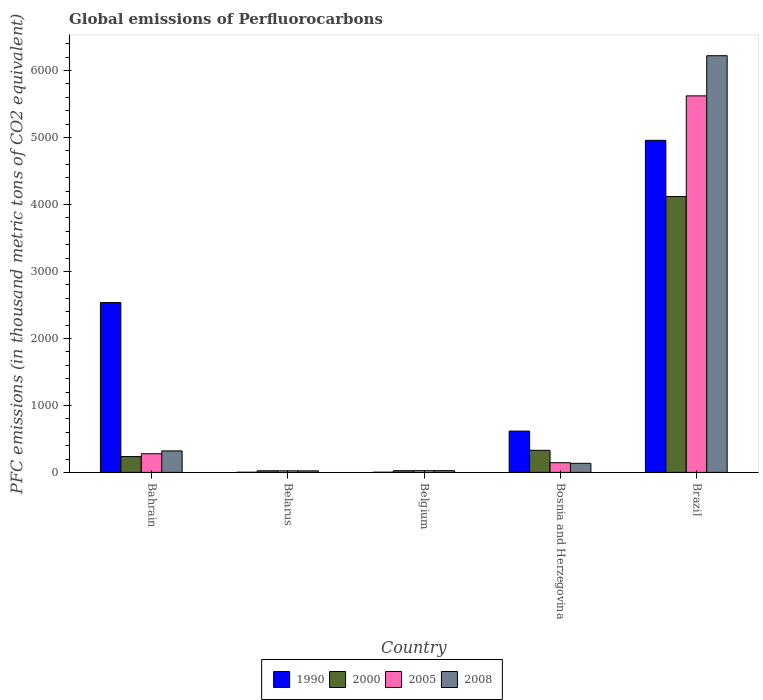How many groups of bars are there?
Give a very brief answer. 5. Are the number of bars per tick equal to the number of legend labels?
Offer a very short reply. Yes. What is the label of the 4th group of bars from the left?
Offer a terse response. Bosnia and Herzegovina. In how many cases, is the number of bars for a given country not equal to the number of legend labels?
Provide a short and direct response. 0. What is the global emissions of Perfluorocarbons in 2008 in Bahrain?
Keep it short and to the point. 320.9. Across all countries, what is the maximum global emissions of Perfluorocarbons in 2000?
Ensure brevity in your answer.  4119.1. In which country was the global emissions of Perfluorocarbons in 2008 maximum?
Provide a short and direct response. Brazil. In which country was the global emissions of Perfluorocarbons in 2008 minimum?
Make the answer very short. Belarus. What is the total global emissions of Perfluorocarbons in 2000 in the graph?
Your answer should be very brief. 4734.2. What is the difference between the global emissions of Perfluorocarbons in 2005 in Belarus and that in Belgium?
Ensure brevity in your answer.  -2.3. What is the difference between the global emissions of Perfluorocarbons in 1990 in Bahrain and the global emissions of Perfluorocarbons in 2005 in Belgium?
Give a very brief answer. 2510. What is the average global emissions of Perfluorocarbons in 2005 per country?
Provide a succinct answer. 1218.84. What is the difference between the global emissions of Perfluorocarbons of/in 1990 and global emissions of Perfluorocarbons of/in 2005 in Bosnia and Herzegovina?
Ensure brevity in your answer.  472.3. What is the ratio of the global emissions of Perfluorocarbons in 2005 in Bahrain to that in Belarus?
Offer a very short reply. 11.91. What is the difference between the highest and the second highest global emissions of Perfluorocarbons in 2008?
Provide a succinct answer. -5900.9. What is the difference between the highest and the lowest global emissions of Perfluorocarbons in 2008?
Give a very brief answer. 6198.7. Is it the case that in every country, the sum of the global emissions of Perfluorocarbons in 2000 and global emissions of Perfluorocarbons in 2008 is greater than the sum of global emissions of Perfluorocarbons in 1990 and global emissions of Perfluorocarbons in 2005?
Offer a very short reply. No. What does the 4th bar from the right in Bosnia and Herzegovina represents?
Your answer should be compact. 1990. How many bars are there?
Provide a succinct answer. 20. Are all the bars in the graph horizontal?
Provide a short and direct response. No. What is the difference between two consecutive major ticks on the Y-axis?
Give a very brief answer. 1000. Does the graph contain any zero values?
Your answer should be compact. No. Does the graph contain grids?
Offer a very short reply. No. Where does the legend appear in the graph?
Give a very brief answer. Bottom center. How many legend labels are there?
Offer a terse response. 4. How are the legend labels stacked?
Offer a terse response. Horizontal. What is the title of the graph?
Give a very brief answer. Global emissions of Perfluorocarbons. Does "1981" appear as one of the legend labels in the graph?
Offer a terse response. No. What is the label or title of the X-axis?
Give a very brief answer. Country. What is the label or title of the Y-axis?
Your answer should be very brief. PFC emissions (in thousand metric tons of CO2 equivalent). What is the PFC emissions (in thousand metric tons of CO2 equivalent) in 1990 in Bahrain?
Make the answer very short. 2535.7. What is the PFC emissions (in thousand metric tons of CO2 equivalent) of 2000 in Bahrain?
Ensure brevity in your answer.  236.1. What is the PFC emissions (in thousand metric tons of CO2 equivalent) in 2005 in Bahrain?
Give a very brief answer. 278.6. What is the PFC emissions (in thousand metric tons of CO2 equivalent) of 2008 in Bahrain?
Provide a succinct answer. 320.9. What is the PFC emissions (in thousand metric tons of CO2 equivalent) in 1990 in Belarus?
Your answer should be compact. 2.6. What is the PFC emissions (in thousand metric tons of CO2 equivalent) in 2000 in Belarus?
Keep it short and to the point. 23.9. What is the PFC emissions (in thousand metric tons of CO2 equivalent) of 2005 in Belarus?
Your answer should be compact. 23.4. What is the PFC emissions (in thousand metric tons of CO2 equivalent) of 2008 in Belarus?
Your answer should be very brief. 23.1. What is the PFC emissions (in thousand metric tons of CO2 equivalent) of 2000 in Belgium?
Your response must be concise. 25.2. What is the PFC emissions (in thousand metric tons of CO2 equivalent) of 2005 in Belgium?
Ensure brevity in your answer.  25.7. What is the PFC emissions (in thousand metric tons of CO2 equivalent) in 1990 in Bosnia and Herzegovina?
Keep it short and to the point. 616.7. What is the PFC emissions (in thousand metric tons of CO2 equivalent) in 2000 in Bosnia and Herzegovina?
Offer a terse response. 329.9. What is the PFC emissions (in thousand metric tons of CO2 equivalent) in 2005 in Bosnia and Herzegovina?
Ensure brevity in your answer.  144.4. What is the PFC emissions (in thousand metric tons of CO2 equivalent) in 2008 in Bosnia and Herzegovina?
Your answer should be compact. 135.6. What is the PFC emissions (in thousand metric tons of CO2 equivalent) of 1990 in Brazil?
Offer a terse response. 4958.1. What is the PFC emissions (in thousand metric tons of CO2 equivalent) in 2000 in Brazil?
Make the answer very short. 4119.1. What is the PFC emissions (in thousand metric tons of CO2 equivalent) of 2005 in Brazil?
Your answer should be very brief. 5622.1. What is the PFC emissions (in thousand metric tons of CO2 equivalent) in 2008 in Brazil?
Your answer should be compact. 6221.8. Across all countries, what is the maximum PFC emissions (in thousand metric tons of CO2 equivalent) of 1990?
Give a very brief answer. 4958.1. Across all countries, what is the maximum PFC emissions (in thousand metric tons of CO2 equivalent) of 2000?
Offer a terse response. 4119.1. Across all countries, what is the maximum PFC emissions (in thousand metric tons of CO2 equivalent) in 2005?
Ensure brevity in your answer.  5622.1. Across all countries, what is the maximum PFC emissions (in thousand metric tons of CO2 equivalent) in 2008?
Offer a terse response. 6221.8. Across all countries, what is the minimum PFC emissions (in thousand metric tons of CO2 equivalent) in 2000?
Provide a succinct answer. 23.9. Across all countries, what is the minimum PFC emissions (in thousand metric tons of CO2 equivalent) of 2005?
Keep it short and to the point. 23.4. Across all countries, what is the minimum PFC emissions (in thousand metric tons of CO2 equivalent) in 2008?
Your answer should be very brief. 23.1. What is the total PFC emissions (in thousand metric tons of CO2 equivalent) of 1990 in the graph?
Provide a succinct answer. 8116. What is the total PFC emissions (in thousand metric tons of CO2 equivalent) of 2000 in the graph?
Offer a terse response. 4734.2. What is the total PFC emissions (in thousand metric tons of CO2 equivalent) of 2005 in the graph?
Make the answer very short. 6094.2. What is the total PFC emissions (in thousand metric tons of CO2 equivalent) of 2008 in the graph?
Ensure brevity in your answer.  6727.4. What is the difference between the PFC emissions (in thousand metric tons of CO2 equivalent) of 1990 in Bahrain and that in Belarus?
Give a very brief answer. 2533.1. What is the difference between the PFC emissions (in thousand metric tons of CO2 equivalent) in 2000 in Bahrain and that in Belarus?
Keep it short and to the point. 212.2. What is the difference between the PFC emissions (in thousand metric tons of CO2 equivalent) in 2005 in Bahrain and that in Belarus?
Make the answer very short. 255.2. What is the difference between the PFC emissions (in thousand metric tons of CO2 equivalent) in 2008 in Bahrain and that in Belarus?
Offer a very short reply. 297.8. What is the difference between the PFC emissions (in thousand metric tons of CO2 equivalent) in 1990 in Bahrain and that in Belgium?
Keep it short and to the point. 2532.8. What is the difference between the PFC emissions (in thousand metric tons of CO2 equivalent) of 2000 in Bahrain and that in Belgium?
Offer a terse response. 210.9. What is the difference between the PFC emissions (in thousand metric tons of CO2 equivalent) of 2005 in Bahrain and that in Belgium?
Your answer should be very brief. 252.9. What is the difference between the PFC emissions (in thousand metric tons of CO2 equivalent) in 2008 in Bahrain and that in Belgium?
Keep it short and to the point. 294.9. What is the difference between the PFC emissions (in thousand metric tons of CO2 equivalent) in 1990 in Bahrain and that in Bosnia and Herzegovina?
Your answer should be very brief. 1919. What is the difference between the PFC emissions (in thousand metric tons of CO2 equivalent) in 2000 in Bahrain and that in Bosnia and Herzegovina?
Your response must be concise. -93.8. What is the difference between the PFC emissions (in thousand metric tons of CO2 equivalent) of 2005 in Bahrain and that in Bosnia and Herzegovina?
Give a very brief answer. 134.2. What is the difference between the PFC emissions (in thousand metric tons of CO2 equivalent) in 2008 in Bahrain and that in Bosnia and Herzegovina?
Provide a succinct answer. 185.3. What is the difference between the PFC emissions (in thousand metric tons of CO2 equivalent) in 1990 in Bahrain and that in Brazil?
Offer a terse response. -2422.4. What is the difference between the PFC emissions (in thousand metric tons of CO2 equivalent) of 2000 in Bahrain and that in Brazil?
Make the answer very short. -3883. What is the difference between the PFC emissions (in thousand metric tons of CO2 equivalent) in 2005 in Bahrain and that in Brazil?
Your answer should be compact. -5343.5. What is the difference between the PFC emissions (in thousand metric tons of CO2 equivalent) in 2008 in Bahrain and that in Brazil?
Your answer should be very brief. -5900.9. What is the difference between the PFC emissions (in thousand metric tons of CO2 equivalent) in 1990 in Belarus and that in Belgium?
Provide a succinct answer. -0.3. What is the difference between the PFC emissions (in thousand metric tons of CO2 equivalent) of 2000 in Belarus and that in Belgium?
Provide a short and direct response. -1.3. What is the difference between the PFC emissions (in thousand metric tons of CO2 equivalent) of 1990 in Belarus and that in Bosnia and Herzegovina?
Your response must be concise. -614.1. What is the difference between the PFC emissions (in thousand metric tons of CO2 equivalent) of 2000 in Belarus and that in Bosnia and Herzegovina?
Provide a short and direct response. -306. What is the difference between the PFC emissions (in thousand metric tons of CO2 equivalent) of 2005 in Belarus and that in Bosnia and Herzegovina?
Provide a succinct answer. -121. What is the difference between the PFC emissions (in thousand metric tons of CO2 equivalent) in 2008 in Belarus and that in Bosnia and Herzegovina?
Keep it short and to the point. -112.5. What is the difference between the PFC emissions (in thousand metric tons of CO2 equivalent) of 1990 in Belarus and that in Brazil?
Make the answer very short. -4955.5. What is the difference between the PFC emissions (in thousand metric tons of CO2 equivalent) in 2000 in Belarus and that in Brazil?
Your answer should be compact. -4095.2. What is the difference between the PFC emissions (in thousand metric tons of CO2 equivalent) in 2005 in Belarus and that in Brazil?
Keep it short and to the point. -5598.7. What is the difference between the PFC emissions (in thousand metric tons of CO2 equivalent) of 2008 in Belarus and that in Brazil?
Make the answer very short. -6198.7. What is the difference between the PFC emissions (in thousand metric tons of CO2 equivalent) of 1990 in Belgium and that in Bosnia and Herzegovina?
Provide a succinct answer. -613.8. What is the difference between the PFC emissions (in thousand metric tons of CO2 equivalent) of 2000 in Belgium and that in Bosnia and Herzegovina?
Give a very brief answer. -304.7. What is the difference between the PFC emissions (in thousand metric tons of CO2 equivalent) of 2005 in Belgium and that in Bosnia and Herzegovina?
Provide a succinct answer. -118.7. What is the difference between the PFC emissions (in thousand metric tons of CO2 equivalent) of 2008 in Belgium and that in Bosnia and Herzegovina?
Provide a short and direct response. -109.6. What is the difference between the PFC emissions (in thousand metric tons of CO2 equivalent) of 1990 in Belgium and that in Brazil?
Your response must be concise. -4955.2. What is the difference between the PFC emissions (in thousand metric tons of CO2 equivalent) in 2000 in Belgium and that in Brazil?
Ensure brevity in your answer.  -4093.9. What is the difference between the PFC emissions (in thousand metric tons of CO2 equivalent) of 2005 in Belgium and that in Brazil?
Offer a very short reply. -5596.4. What is the difference between the PFC emissions (in thousand metric tons of CO2 equivalent) in 2008 in Belgium and that in Brazil?
Provide a short and direct response. -6195.8. What is the difference between the PFC emissions (in thousand metric tons of CO2 equivalent) in 1990 in Bosnia and Herzegovina and that in Brazil?
Offer a very short reply. -4341.4. What is the difference between the PFC emissions (in thousand metric tons of CO2 equivalent) of 2000 in Bosnia and Herzegovina and that in Brazil?
Offer a very short reply. -3789.2. What is the difference between the PFC emissions (in thousand metric tons of CO2 equivalent) of 2005 in Bosnia and Herzegovina and that in Brazil?
Offer a terse response. -5477.7. What is the difference between the PFC emissions (in thousand metric tons of CO2 equivalent) in 2008 in Bosnia and Herzegovina and that in Brazil?
Ensure brevity in your answer.  -6086.2. What is the difference between the PFC emissions (in thousand metric tons of CO2 equivalent) in 1990 in Bahrain and the PFC emissions (in thousand metric tons of CO2 equivalent) in 2000 in Belarus?
Your answer should be compact. 2511.8. What is the difference between the PFC emissions (in thousand metric tons of CO2 equivalent) in 1990 in Bahrain and the PFC emissions (in thousand metric tons of CO2 equivalent) in 2005 in Belarus?
Offer a terse response. 2512.3. What is the difference between the PFC emissions (in thousand metric tons of CO2 equivalent) of 1990 in Bahrain and the PFC emissions (in thousand metric tons of CO2 equivalent) of 2008 in Belarus?
Your response must be concise. 2512.6. What is the difference between the PFC emissions (in thousand metric tons of CO2 equivalent) of 2000 in Bahrain and the PFC emissions (in thousand metric tons of CO2 equivalent) of 2005 in Belarus?
Give a very brief answer. 212.7. What is the difference between the PFC emissions (in thousand metric tons of CO2 equivalent) of 2000 in Bahrain and the PFC emissions (in thousand metric tons of CO2 equivalent) of 2008 in Belarus?
Provide a short and direct response. 213. What is the difference between the PFC emissions (in thousand metric tons of CO2 equivalent) in 2005 in Bahrain and the PFC emissions (in thousand metric tons of CO2 equivalent) in 2008 in Belarus?
Offer a terse response. 255.5. What is the difference between the PFC emissions (in thousand metric tons of CO2 equivalent) in 1990 in Bahrain and the PFC emissions (in thousand metric tons of CO2 equivalent) in 2000 in Belgium?
Make the answer very short. 2510.5. What is the difference between the PFC emissions (in thousand metric tons of CO2 equivalent) of 1990 in Bahrain and the PFC emissions (in thousand metric tons of CO2 equivalent) of 2005 in Belgium?
Your answer should be compact. 2510. What is the difference between the PFC emissions (in thousand metric tons of CO2 equivalent) of 1990 in Bahrain and the PFC emissions (in thousand metric tons of CO2 equivalent) of 2008 in Belgium?
Give a very brief answer. 2509.7. What is the difference between the PFC emissions (in thousand metric tons of CO2 equivalent) in 2000 in Bahrain and the PFC emissions (in thousand metric tons of CO2 equivalent) in 2005 in Belgium?
Keep it short and to the point. 210.4. What is the difference between the PFC emissions (in thousand metric tons of CO2 equivalent) of 2000 in Bahrain and the PFC emissions (in thousand metric tons of CO2 equivalent) of 2008 in Belgium?
Offer a terse response. 210.1. What is the difference between the PFC emissions (in thousand metric tons of CO2 equivalent) in 2005 in Bahrain and the PFC emissions (in thousand metric tons of CO2 equivalent) in 2008 in Belgium?
Your answer should be compact. 252.6. What is the difference between the PFC emissions (in thousand metric tons of CO2 equivalent) in 1990 in Bahrain and the PFC emissions (in thousand metric tons of CO2 equivalent) in 2000 in Bosnia and Herzegovina?
Ensure brevity in your answer.  2205.8. What is the difference between the PFC emissions (in thousand metric tons of CO2 equivalent) in 1990 in Bahrain and the PFC emissions (in thousand metric tons of CO2 equivalent) in 2005 in Bosnia and Herzegovina?
Make the answer very short. 2391.3. What is the difference between the PFC emissions (in thousand metric tons of CO2 equivalent) of 1990 in Bahrain and the PFC emissions (in thousand metric tons of CO2 equivalent) of 2008 in Bosnia and Herzegovina?
Give a very brief answer. 2400.1. What is the difference between the PFC emissions (in thousand metric tons of CO2 equivalent) of 2000 in Bahrain and the PFC emissions (in thousand metric tons of CO2 equivalent) of 2005 in Bosnia and Herzegovina?
Make the answer very short. 91.7. What is the difference between the PFC emissions (in thousand metric tons of CO2 equivalent) of 2000 in Bahrain and the PFC emissions (in thousand metric tons of CO2 equivalent) of 2008 in Bosnia and Herzegovina?
Your answer should be very brief. 100.5. What is the difference between the PFC emissions (in thousand metric tons of CO2 equivalent) in 2005 in Bahrain and the PFC emissions (in thousand metric tons of CO2 equivalent) in 2008 in Bosnia and Herzegovina?
Your answer should be compact. 143. What is the difference between the PFC emissions (in thousand metric tons of CO2 equivalent) in 1990 in Bahrain and the PFC emissions (in thousand metric tons of CO2 equivalent) in 2000 in Brazil?
Make the answer very short. -1583.4. What is the difference between the PFC emissions (in thousand metric tons of CO2 equivalent) of 1990 in Bahrain and the PFC emissions (in thousand metric tons of CO2 equivalent) of 2005 in Brazil?
Offer a very short reply. -3086.4. What is the difference between the PFC emissions (in thousand metric tons of CO2 equivalent) in 1990 in Bahrain and the PFC emissions (in thousand metric tons of CO2 equivalent) in 2008 in Brazil?
Offer a very short reply. -3686.1. What is the difference between the PFC emissions (in thousand metric tons of CO2 equivalent) of 2000 in Bahrain and the PFC emissions (in thousand metric tons of CO2 equivalent) of 2005 in Brazil?
Keep it short and to the point. -5386. What is the difference between the PFC emissions (in thousand metric tons of CO2 equivalent) in 2000 in Bahrain and the PFC emissions (in thousand metric tons of CO2 equivalent) in 2008 in Brazil?
Offer a very short reply. -5985.7. What is the difference between the PFC emissions (in thousand metric tons of CO2 equivalent) in 2005 in Bahrain and the PFC emissions (in thousand metric tons of CO2 equivalent) in 2008 in Brazil?
Provide a succinct answer. -5943.2. What is the difference between the PFC emissions (in thousand metric tons of CO2 equivalent) in 1990 in Belarus and the PFC emissions (in thousand metric tons of CO2 equivalent) in 2000 in Belgium?
Your answer should be compact. -22.6. What is the difference between the PFC emissions (in thousand metric tons of CO2 equivalent) of 1990 in Belarus and the PFC emissions (in thousand metric tons of CO2 equivalent) of 2005 in Belgium?
Your answer should be compact. -23.1. What is the difference between the PFC emissions (in thousand metric tons of CO2 equivalent) of 1990 in Belarus and the PFC emissions (in thousand metric tons of CO2 equivalent) of 2008 in Belgium?
Make the answer very short. -23.4. What is the difference between the PFC emissions (in thousand metric tons of CO2 equivalent) of 2000 in Belarus and the PFC emissions (in thousand metric tons of CO2 equivalent) of 2005 in Belgium?
Offer a terse response. -1.8. What is the difference between the PFC emissions (in thousand metric tons of CO2 equivalent) of 2000 in Belarus and the PFC emissions (in thousand metric tons of CO2 equivalent) of 2008 in Belgium?
Your response must be concise. -2.1. What is the difference between the PFC emissions (in thousand metric tons of CO2 equivalent) of 1990 in Belarus and the PFC emissions (in thousand metric tons of CO2 equivalent) of 2000 in Bosnia and Herzegovina?
Ensure brevity in your answer.  -327.3. What is the difference between the PFC emissions (in thousand metric tons of CO2 equivalent) of 1990 in Belarus and the PFC emissions (in thousand metric tons of CO2 equivalent) of 2005 in Bosnia and Herzegovina?
Provide a short and direct response. -141.8. What is the difference between the PFC emissions (in thousand metric tons of CO2 equivalent) of 1990 in Belarus and the PFC emissions (in thousand metric tons of CO2 equivalent) of 2008 in Bosnia and Herzegovina?
Your answer should be very brief. -133. What is the difference between the PFC emissions (in thousand metric tons of CO2 equivalent) in 2000 in Belarus and the PFC emissions (in thousand metric tons of CO2 equivalent) in 2005 in Bosnia and Herzegovina?
Keep it short and to the point. -120.5. What is the difference between the PFC emissions (in thousand metric tons of CO2 equivalent) of 2000 in Belarus and the PFC emissions (in thousand metric tons of CO2 equivalent) of 2008 in Bosnia and Herzegovina?
Ensure brevity in your answer.  -111.7. What is the difference between the PFC emissions (in thousand metric tons of CO2 equivalent) of 2005 in Belarus and the PFC emissions (in thousand metric tons of CO2 equivalent) of 2008 in Bosnia and Herzegovina?
Provide a succinct answer. -112.2. What is the difference between the PFC emissions (in thousand metric tons of CO2 equivalent) in 1990 in Belarus and the PFC emissions (in thousand metric tons of CO2 equivalent) in 2000 in Brazil?
Your answer should be compact. -4116.5. What is the difference between the PFC emissions (in thousand metric tons of CO2 equivalent) of 1990 in Belarus and the PFC emissions (in thousand metric tons of CO2 equivalent) of 2005 in Brazil?
Provide a succinct answer. -5619.5. What is the difference between the PFC emissions (in thousand metric tons of CO2 equivalent) in 1990 in Belarus and the PFC emissions (in thousand metric tons of CO2 equivalent) in 2008 in Brazil?
Ensure brevity in your answer.  -6219.2. What is the difference between the PFC emissions (in thousand metric tons of CO2 equivalent) of 2000 in Belarus and the PFC emissions (in thousand metric tons of CO2 equivalent) of 2005 in Brazil?
Your answer should be compact. -5598.2. What is the difference between the PFC emissions (in thousand metric tons of CO2 equivalent) of 2000 in Belarus and the PFC emissions (in thousand metric tons of CO2 equivalent) of 2008 in Brazil?
Keep it short and to the point. -6197.9. What is the difference between the PFC emissions (in thousand metric tons of CO2 equivalent) of 2005 in Belarus and the PFC emissions (in thousand metric tons of CO2 equivalent) of 2008 in Brazil?
Your response must be concise. -6198.4. What is the difference between the PFC emissions (in thousand metric tons of CO2 equivalent) in 1990 in Belgium and the PFC emissions (in thousand metric tons of CO2 equivalent) in 2000 in Bosnia and Herzegovina?
Provide a short and direct response. -327. What is the difference between the PFC emissions (in thousand metric tons of CO2 equivalent) of 1990 in Belgium and the PFC emissions (in thousand metric tons of CO2 equivalent) of 2005 in Bosnia and Herzegovina?
Ensure brevity in your answer.  -141.5. What is the difference between the PFC emissions (in thousand metric tons of CO2 equivalent) in 1990 in Belgium and the PFC emissions (in thousand metric tons of CO2 equivalent) in 2008 in Bosnia and Herzegovina?
Your answer should be very brief. -132.7. What is the difference between the PFC emissions (in thousand metric tons of CO2 equivalent) of 2000 in Belgium and the PFC emissions (in thousand metric tons of CO2 equivalent) of 2005 in Bosnia and Herzegovina?
Offer a very short reply. -119.2. What is the difference between the PFC emissions (in thousand metric tons of CO2 equivalent) of 2000 in Belgium and the PFC emissions (in thousand metric tons of CO2 equivalent) of 2008 in Bosnia and Herzegovina?
Your response must be concise. -110.4. What is the difference between the PFC emissions (in thousand metric tons of CO2 equivalent) of 2005 in Belgium and the PFC emissions (in thousand metric tons of CO2 equivalent) of 2008 in Bosnia and Herzegovina?
Provide a succinct answer. -109.9. What is the difference between the PFC emissions (in thousand metric tons of CO2 equivalent) in 1990 in Belgium and the PFC emissions (in thousand metric tons of CO2 equivalent) in 2000 in Brazil?
Offer a very short reply. -4116.2. What is the difference between the PFC emissions (in thousand metric tons of CO2 equivalent) of 1990 in Belgium and the PFC emissions (in thousand metric tons of CO2 equivalent) of 2005 in Brazil?
Provide a short and direct response. -5619.2. What is the difference between the PFC emissions (in thousand metric tons of CO2 equivalent) in 1990 in Belgium and the PFC emissions (in thousand metric tons of CO2 equivalent) in 2008 in Brazil?
Offer a very short reply. -6218.9. What is the difference between the PFC emissions (in thousand metric tons of CO2 equivalent) of 2000 in Belgium and the PFC emissions (in thousand metric tons of CO2 equivalent) of 2005 in Brazil?
Make the answer very short. -5596.9. What is the difference between the PFC emissions (in thousand metric tons of CO2 equivalent) in 2000 in Belgium and the PFC emissions (in thousand metric tons of CO2 equivalent) in 2008 in Brazil?
Provide a short and direct response. -6196.6. What is the difference between the PFC emissions (in thousand metric tons of CO2 equivalent) in 2005 in Belgium and the PFC emissions (in thousand metric tons of CO2 equivalent) in 2008 in Brazil?
Offer a very short reply. -6196.1. What is the difference between the PFC emissions (in thousand metric tons of CO2 equivalent) of 1990 in Bosnia and Herzegovina and the PFC emissions (in thousand metric tons of CO2 equivalent) of 2000 in Brazil?
Offer a terse response. -3502.4. What is the difference between the PFC emissions (in thousand metric tons of CO2 equivalent) of 1990 in Bosnia and Herzegovina and the PFC emissions (in thousand metric tons of CO2 equivalent) of 2005 in Brazil?
Make the answer very short. -5005.4. What is the difference between the PFC emissions (in thousand metric tons of CO2 equivalent) of 1990 in Bosnia and Herzegovina and the PFC emissions (in thousand metric tons of CO2 equivalent) of 2008 in Brazil?
Your answer should be compact. -5605.1. What is the difference between the PFC emissions (in thousand metric tons of CO2 equivalent) in 2000 in Bosnia and Herzegovina and the PFC emissions (in thousand metric tons of CO2 equivalent) in 2005 in Brazil?
Give a very brief answer. -5292.2. What is the difference between the PFC emissions (in thousand metric tons of CO2 equivalent) of 2000 in Bosnia and Herzegovina and the PFC emissions (in thousand metric tons of CO2 equivalent) of 2008 in Brazil?
Make the answer very short. -5891.9. What is the difference between the PFC emissions (in thousand metric tons of CO2 equivalent) of 2005 in Bosnia and Herzegovina and the PFC emissions (in thousand metric tons of CO2 equivalent) of 2008 in Brazil?
Provide a succinct answer. -6077.4. What is the average PFC emissions (in thousand metric tons of CO2 equivalent) in 1990 per country?
Offer a terse response. 1623.2. What is the average PFC emissions (in thousand metric tons of CO2 equivalent) in 2000 per country?
Provide a succinct answer. 946.84. What is the average PFC emissions (in thousand metric tons of CO2 equivalent) of 2005 per country?
Provide a succinct answer. 1218.84. What is the average PFC emissions (in thousand metric tons of CO2 equivalent) in 2008 per country?
Your response must be concise. 1345.48. What is the difference between the PFC emissions (in thousand metric tons of CO2 equivalent) of 1990 and PFC emissions (in thousand metric tons of CO2 equivalent) of 2000 in Bahrain?
Make the answer very short. 2299.6. What is the difference between the PFC emissions (in thousand metric tons of CO2 equivalent) in 1990 and PFC emissions (in thousand metric tons of CO2 equivalent) in 2005 in Bahrain?
Give a very brief answer. 2257.1. What is the difference between the PFC emissions (in thousand metric tons of CO2 equivalent) of 1990 and PFC emissions (in thousand metric tons of CO2 equivalent) of 2008 in Bahrain?
Your answer should be very brief. 2214.8. What is the difference between the PFC emissions (in thousand metric tons of CO2 equivalent) of 2000 and PFC emissions (in thousand metric tons of CO2 equivalent) of 2005 in Bahrain?
Ensure brevity in your answer.  -42.5. What is the difference between the PFC emissions (in thousand metric tons of CO2 equivalent) of 2000 and PFC emissions (in thousand metric tons of CO2 equivalent) of 2008 in Bahrain?
Make the answer very short. -84.8. What is the difference between the PFC emissions (in thousand metric tons of CO2 equivalent) in 2005 and PFC emissions (in thousand metric tons of CO2 equivalent) in 2008 in Bahrain?
Your answer should be compact. -42.3. What is the difference between the PFC emissions (in thousand metric tons of CO2 equivalent) of 1990 and PFC emissions (in thousand metric tons of CO2 equivalent) of 2000 in Belarus?
Provide a succinct answer. -21.3. What is the difference between the PFC emissions (in thousand metric tons of CO2 equivalent) of 1990 and PFC emissions (in thousand metric tons of CO2 equivalent) of 2005 in Belarus?
Offer a very short reply. -20.8. What is the difference between the PFC emissions (in thousand metric tons of CO2 equivalent) in 1990 and PFC emissions (in thousand metric tons of CO2 equivalent) in 2008 in Belarus?
Give a very brief answer. -20.5. What is the difference between the PFC emissions (in thousand metric tons of CO2 equivalent) of 2000 and PFC emissions (in thousand metric tons of CO2 equivalent) of 2005 in Belarus?
Your answer should be very brief. 0.5. What is the difference between the PFC emissions (in thousand metric tons of CO2 equivalent) of 2000 and PFC emissions (in thousand metric tons of CO2 equivalent) of 2008 in Belarus?
Keep it short and to the point. 0.8. What is the difference between the PFC emissions (in thousand metric tons of CO2 equivalent) in 2005 and PFC emissions (in thousand metric tons of CO2 equivalent) in 2008 in Belarus?
Ensure brevity in your answer.  0.3. What is the difference between the PFC emissions (in thousand metric tons of CO2 equivalent) in 1990 and PFC emissions (in thousand metric tons of CO2 equivalent) in 2000 in Belgium?
Offer a very short reply. -22.3. What is the difference between the PFC emissions (in thousand metric tons of CO2 equivalent) of 1990 and PFC emissions (in thousand metric tons of CO2 equivalent) of 2005 in Belgium?
Offer a terse response. -22.8. What is the difference between the PFC emissions (in thousand metric tons of CO2 equivalent) of 1990 and PFC emissions (in thousand metric tons of CO2 equivalent) of 2008 in Belgium?
Offer a terse response. -23.1. What is the difference between the PFC emissions (in thousand metric tons of CO2 equivalent) in 2000 and PFC emissions (in thousand metric tons of CO2 equivalent) in 2005 in Belgium?
Provide a succinct answer. -0.5. What is the difference between the PFC emissions (in thousand metric tons of CO2 equivalent) in 2000 and PFC emissions (in thousand metric tons of CO2 equivalent) in 2008 in Belgium?
Your response must be concise. -0.8. What is the difference between the PFC emissions (in thousand metric tons of CO2 equivalent) of 1990 and PFC emissions (in thousand metric tons of CO2 equivalent) of 2000 in Bosnia and Herzegovina?
Your answer should be very brief. 286.8. What is the difference between the PFC emissions (in thousand metric tons of CO2 equivalent) in 1990 and PFC emissions (in thousand metric tons of CO2 equivalent) in 2005 in Bosnia and Herzegovina?
Keep it short and to the point. 472.3. What is the difference between the PFC emissions (in thousand metric tons of CO2 equivalent) in 1990 and PFC emissions (in thousand metric tons of CO2 equivalent) in 2008 in Bosnia and Herzegovina?
Your answer should be compact. 481.1. What is the difference between the PFC emissions (in thousand metric tons of CO2 equivalent) of 2000 and PFC emissions (in thousand metric tons of CO2 equivalent) of 2005 in Bosnia and Herzegovina?
Offer a terse response. 185.5. What is the difference between the PFC emissions (in thousand metric tons of CO2 equivalent) of 2000 and PFC emissions (in thousand metric tons of CO2 equivalent) of 2008 in Bosnia and Herzegovina?
Offer a terse response. 194.3. What is the difference between the PFC emissions (in thousand metric tons of CO2 equivalent) in 1990 and PFC emissions (in thousand metric tons of CO2 equivalent) in 2000 in Brazil?
Provide a short and direct response. 839. What is the difference between the PFC emissions (in thousand metric tons of CO2 equivalent) of 1990 and PFC emissions (in thousand metric tons of CO2 equivalent) of 2005 in Brazil?
Make the answer very short. -664. What is the difference between the PFC emissions (in thousand metric tons of CO2 equivalent) in 1990 and PFC emissions (in thousand metric tons of CO2 equivalent) in 2008 in Brazil?
Offer a very short reply. -1263.7. What is the difference between the PFC emissions (in thousand metric tons of CO2 equivalent) in 2000 and PFC emissions (in thousand metric tons of CO2 equivalent) in 2005 in Brazil?
Provide a succinct answer. -1503. What is the difference between the PFC emissions (in thousand metric tons of CO2 equivalent) in 2000 and PFC emissions (in thousand metric tons of CO2 equivalent) in 2008 in Brazil?
Offer a terse response. -2102.7. What is the difference between the PFC emissions (in thousand metric tons of CO2 equivalent) in 2005 and PFC emissions (in thousand metric tons of CO2 equivalent) in 2008 in Brazil?
Ensure brevity in your answer.  -599.7. What is the ratio of the PFC emissions (in thousand metric tons of CO2 equivalent) in 1990 in Bahrain to that in Belarus?
Your answer should be very brief. 975.27. What is the ratio of the PFC emissions (in thousand metric tons of CO2 equivalent) in 2000 in Bahrain to that in Belarus?
Offer a very short reply. 9.88. What is the ratio of the PFC emissions (in thousand metric tons of CO2 equivalent) in 2005 in Bahrain to that in Belarus?
Provide a short and direct response. 11.91. What is the ratio of the PFC emissions (in thousand metric tons of CO2 equivalent) in 2008 in Bahrain to that in Belarus?
Give a very brief answer. 13.89. What is the ratio of the PFC emissions (in thousand metric tons of CO2 equivalent) in 1990 in Bahrain to that in Belgium?
Provide a succinct answer. 874.38. What is the ratio of the PFC emissions (in thousand metric tons of CO2 equivalent) in 2000 in Bahrain to that in Belgium?
Offer a terse response. 9.37. What is the ratio of the PFC emissions (in thousand metric tons of CO2 equivalent) of 2005 in Bahrain to that in Belgium?
Give a very brief answer. 10.84. What is the ratio of the PFC emissions (in thousand metric tons of CO2 equivalent) of 2008 in Bahrain to that in Belgium?
Provide a succinct answer. 12.34. What is the ratio of the PFC emissions (in thousand metric tons of CO2 equivalent) of 1990 in Bahrain to that in Bosnia and Herzegovina?
Your answer should be compact. 4.11. What is the ratio of the PFC emissions (in thousand metric tons of CO2 equivalent) in 2000 in Bahrain to that in Bosnia and Herzegovina?
Make the answer very short. 0.72. What is the ratio of the PFC emissions (in thousand metric tons of CO2 equivalent) of 2005 in Bahrain to that in Bosnia and Herzegovina?
Your response must be concise. 1.93. What is the ratio of the PFC emissions (in thousand metric tons of CO2 equivalent) of 2008 in Bahrain to that in Bosnia and Herzegovina?
Give a very brief answer. 2.37. What is the ratio of the PFC emissions (in thousand metric tons of CO2 equivalent) in 1990 in Bahrain to that in Brazil?
Your response must be concise. 0.51. What is the ratio of the PFC emissions (in thousand metric tons of CO2 equivalent) in 2000 in Bahrain to that in Brazil?
Make the answer very short. 0.06. What is the ratio of the PFC emissions (in thousand metric tons of CO2 equivalent) of 2005 in Bahrain to that in Brazil?
Keep it short and to the point. 0.05. What is the ratio of the PFC emissions (in thousand metric tons of CO2 equivalent) of 2008 in Bahrain to that in Brazil?
Provide a succinct answer. 0.05. What is the ratio of the PFC emissions (in thousand metric tons of CO2 equivalent) of 1990 in Belarus to that in Belgium?
Make the answer very short. 0.9. What is the ratio of the PFC emissions (in thousand metric tons of CO2 equivalent) of 2000 in Belarus to that in Belgium?
Offer a terse response. 0.95. What is the ratio of the PFC emissions (in thousand metric tons of CO2 equivalent) of 2005 in Belarus to that in Belgium?
Provide a succinct answer. 0.91. What is the ratio of the PFC emissions (in thousand metric tons of CO2 equivalent) of 2008 in Belarus to that in Belgium?
Make the answer very short. 0.89. What is the ratio of the PFC emissions (in thousand metric tons of CO2 equivalent) of 1990 in Belarus to that in Bosnia and Herzegovina?
Provide a succinct answer. 0. What is the ratio of the PFC emissions (in thousand metric tons of CO2 equivalent) of 2000 in Belarus to that in Bosnia and Herzegovina?
Make the answer very short. 0.07. What is the ratio of the PFC emissions (in thousand metric tons of CO2 equivalent) in 2005 in Belarus to that in Bosnia and Herzegovina?
Your answer should be very brief. 0.16. What is the ratio of the PFC emissions (in thousand metric tons of CO2 equivalent) in 2008 in Belarus to that in Bosnia and Herzegovina?
Your answer should be compact. 0.17. What is the ratio of the PFC emissions (in thousand metric tons of CO2 equivalent) in 1990 in Belarus to that in Brazil?
Offer a terse response. 0. What is the ratio of the PFC emissions (in thousand metric tons of CO2 equivalent) in 2000 in Belarus to that in Brazil?
Ensure brevity in your answer.  0.01. What is the ratio of the PFC emissions (in thousand metric tons of CO2 equivalent) of 2005 in Belarus to that in Brazil?
Your answer should be very brief. 0. What is the ratio of the PFC emissions (in thousand metric tons of CO2 equivalent) in 2008 in Belarus to that in Brazil?
Provide a short and direct response. 0. What is the ratio of the PFC emissions (in thousand metric tons of CO2 equivalent) in 1990 in Belgium to that in Bosnia and Herzegovina?
Offer a terse response. 0. What is the ratio of the PFC emissions (in thousand metric tons of CO2 equivalent) in 2000 in Belgium to that in Bosnia and Herzegovina?
Provide a short and direct response. 0.08. What is the ratio of the PFC emissions (in thousand metric tons of CO2 equivalent) in 2005 in Belgium to that in Bosnia and Herzegovina?
Ensure brevity in your answer.  0.18. What is the ratio of the PFC emissions (in thousand metric tons of CO2 equivalent) in 2008 in Belgium to that in Bosnia and Herzegovina?
Offer a terse response. 0.19. What is the ratio of the PFC emissions (in thousand metric tons of CO2 equivalent) of 1990 in Belgium to that in Brazil?
Make the answer very short. 0. What is the ratio of the PFC emissions (in thousand metric tons of CO2 equivalent) in 2000 in Belgium to that in Brazil?
Ensure brevity in your answer.  0.01. What is the ratio of the PFC emissions (in thousand metric tons of CO2 equivalent) of 2005 in Belgium to that in Brazil?
Your answer should be compact. 0. What is the ratio of the PFC emissions (in thousand metric tons of CO2 equivalent) of 2008 in Belgium to that in Brazil?
Your answer should be compact. 0. What is the ratio of the PFC emissions (in thousand metric tons of CO2 equivalent) in 1990 in Bosnia and Herzegovina to that in Brazil?
Provide a succinct answer. 0.12. What is the ratio of the PFC emissions (in thousand metric tons of CO2 equivalent) of 2000 in Bosnia and Herzegovina to that in Brazil?
Offer a very short reply. 0.08. What is the ratio of the PFC emissions (in thousand metric tons of CO2 equivalent) in 2005 in Bosnia and Herzegovina to that in Brazil?
Offer a terse response. 0.03. What is the ratio of the PFC emissions (in thousand metric tons of CO2 equivalent) in 2008 in Bosnia and Herzegovina to that in Brazil?
Give a very brief answer. 0.02. What is the difference between the highest and the second highest PFC emissions (in thousand metric tons of CO2 equivalent) in 1990?
Offer a very short reply. 2422.4. What is the difference between the highest and the second highest PFC emissions (in thousand metric tons of CO2 equivalent) of 2000?
Give a very brief answer. 3789.2. What is the difference between the highest and the second highest PFC emissions (in thousand metric tons of CO2 equivalent) in 2005?
Keep it short and to the point. 5343.5. What is the difference between the highest and the second highest PFC emissions (in thousand metric tons of CO2 equivalent) in 2008?
Ensure brevity in your answer.  5900.9. What is the difference between the highest and the lowest PFC emissions (in thousand metric tons of CO2 equivalent) in 1990?
Offer a terse response. 4955.5. What is the difference between the highest and the lowest PFC emissions (in thousand metric tons of CO2 equivalent) in 2000?
Keep it short and to the point. 4095.2. What is the difference between the highest and the lowest PFC emissions (in thousand metric tons of CO2 equivalent) in 2005?
Provide a succinct answer. 5598.7. What is the difference between the highest and the lowest PFC emissions (in thousand metric tons of CO2 equivalent) of 2008?
Offer a terse response. 6198.7. 